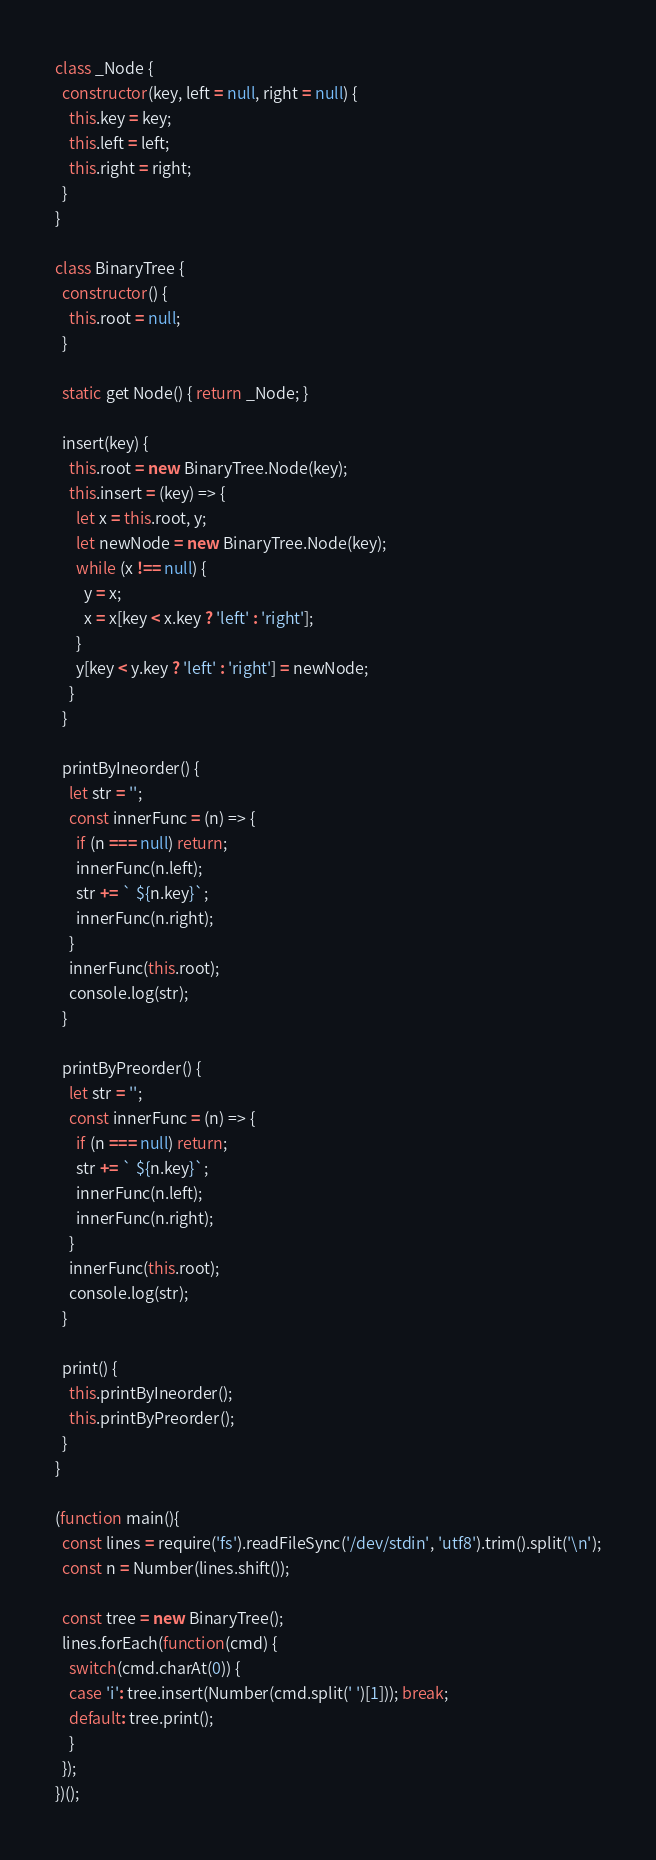Convert code to text. <code><loc_0><loc_0><loc_500><loc_500><_JavaScript_>class _Node {
  constructor(key, left = null, right = null) {
    this.key = key;
    this.left = left;
    this.right = right;
  }
}

class BinaryTree {
  constructor() {
    this.root = null;
  }

  static get Node() { return _Node; }

  insert(key) {
    this.root = new BinaryTree.Node(key);
    this.insert = (key) => {
      let x = this.root, y;
      let newNode = new BinaryTree.Node(key);
      while (x !== null) {
        y = x;
        x = x[key < x.key ? 'left' : 'right'];
      }
      y[key < y.key ? 'left' : 'right'] = newNode;
    }
  }

  printByIneorder() {
    let str = '';
    const innerFunc = (n) => {
      if (n === null) return;
      innerFunc(n.left);
      str += ` ${n.key}`;
      innerFunc(n.right);
    }
    innerFunc(this.root);
    console.log(str);
  }

  printByPreorder() {
    let str = '';
    const innerFunc = (n) => {
      if (n === null) return;
      str += ` ${n.key}`;
      innerFunc(n.left);
      innerFunc(n.right);
    }
    innerFunc(this.root);
    console.log(str);
  }

  print() {
    this.printByIneorder();
    this.printByPreorder();
  }
}

(function main(){
  const lines = require('fs').readFileSync('/dev/stdin', 'utf8').trim().split('\n');
  const n = Number(lines.shift());

  const tree = new BinaryTree();
  lines.forEach(function(cmd) {
    switch(cmd.charAt(0)) {
    case 'i': tree.insert(Number(cmd.split(' ')[1])); break;
    default: tree.print();
    }
  });
})();

</code> 